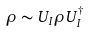<formula> <loc_0><loc_0><loc_500><loc_500>\rho \sim U _ { I } \rho U _ { I } ^ { \dagger }</formula> 